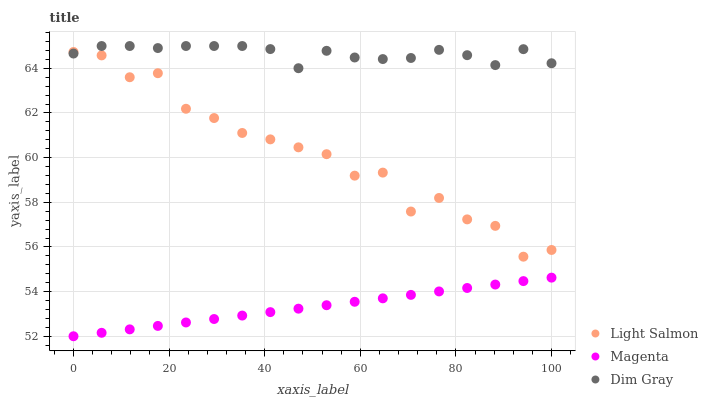Does Magenta have the minimum area under the curve?
Answer yes or no. Yes. Does Dim Gray have the maximum area under the curve?
Answer yes or no. Yes. Does Dim Gray have the minimum area under the curve?
Answer yes or no. No. Does Magenta have the maximum area under the curve?
Answer yes or no. No. Is Magenta the smoothest?
Answer yes or no. Yes. Is Light Salmon the roughest?
Answer yes or no. Yes. Is Dim Gray the smoothest?
Answer yes or no. No. Is Dim Gray the roughest?
Answer yes or no. No. Does Magenta have the lowest value?
Answer yes or no. Yes. Does Dim Gray have the lowest value?
Answer yes or no. No. Does Dim Gray have the highest value?
Answer yes or no. Yes. Does Magenta have the highest value?
Answer yes or no. No. Is Magenta less than Dim Gray?
Answer yes or no. Yes. Is Light Salmon greater than Magenta?
Answer yes or no. Yes. Does Light Salmon intersect Dim Gray?
Answer yes or no. Yes. Is Light Salmon less than Dim Gray?
Answer yes or no. No. Is Light Salmon greater than Dim Gray?
Answer yes or no. No. Does Magenta intersect Dim Gray?
Answer yes or no. No. 